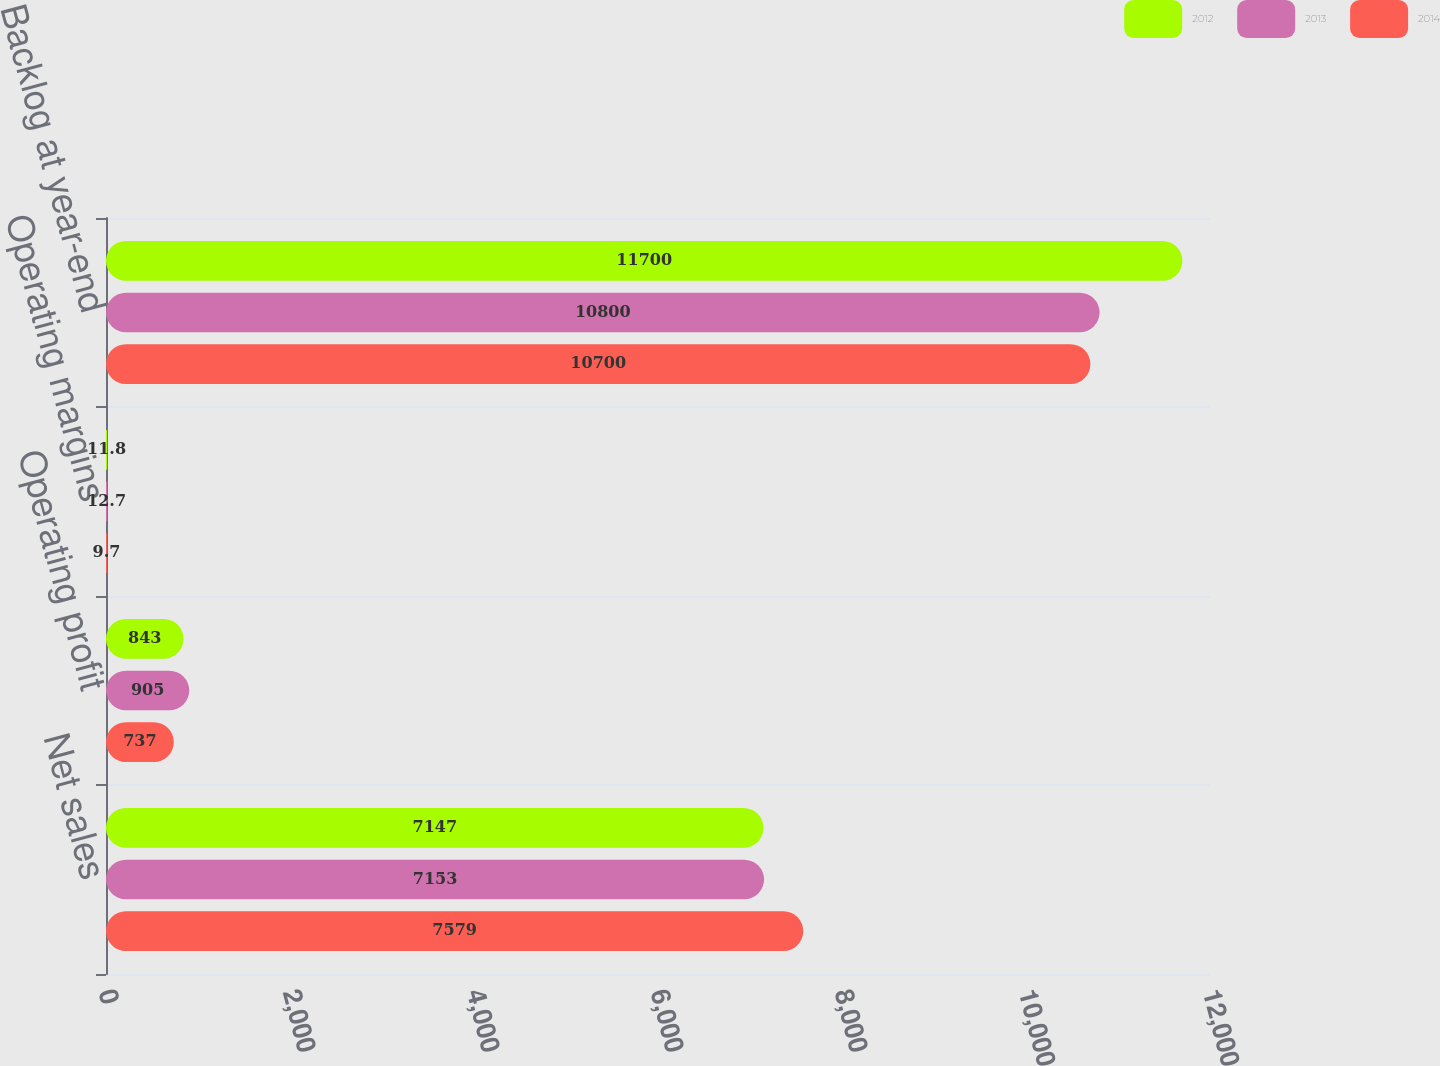Convert chart. <chart><loc_0><loc_0><loc_500><loc_500><stacked_bar_chart><ecel><fcel>Net sales<fcel>Operating profit<fcel>Operating margins<fcel>Backlog at year-end<nl><fcel>2012<fcel>7147<fcel>843<fcel>11.8<fcel>11700<nl><fcel>2013<fcel>7153<fcel>905<fcel>12.7<fcel>10800<nl><fcel>2014<fcel>7579<fcel>737<fcel>9.7<fcel>10700<nl></chart> 